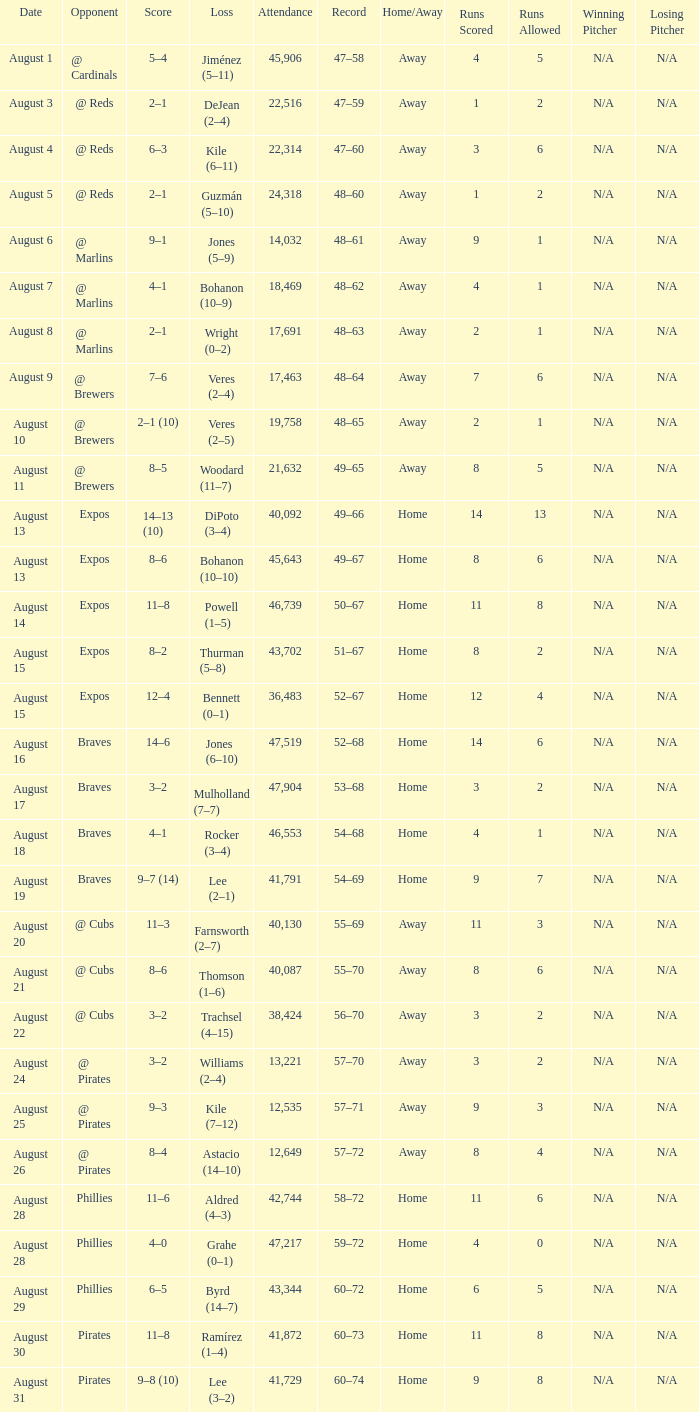What is the lowest attendance total on August 26? 12649.0. 